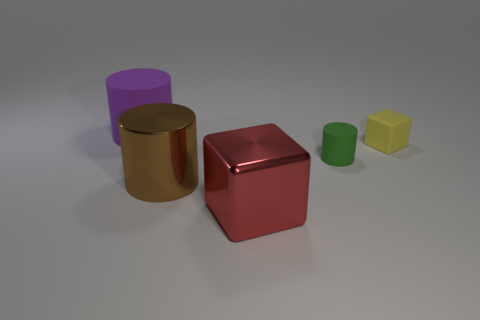Is the shape of the green object the same as the purple matte object?
Ensure brevity in your answer.  Yes. What number of tiny green objects have the same shape as the large rubber object?
Your response must be concise. 1. What number of blocks are on the right side of the small green object?
Provide a short and direct response. 1. How many red shiny cubes are the same size as the green thing?
Provide a short and direct response. 0. There is a thing that is made of the same material as the red block; what is its shape?
Offer a very short reply. Cylinder. Is there a large rubber cube of the same color as the big metal cylinder?
Your answer should be compact. No. What is the material of the red block?
Offer a terse response. Metal. How many objects are either big brown cylinders or purple things?
Make the answer very short. 2. What size is the block that is on the right side of the red cube?
Ensure brevity in your answer.  Small. How many other things are made of the same material as the tiny yellow cube?
Make the answer very short. 2. 